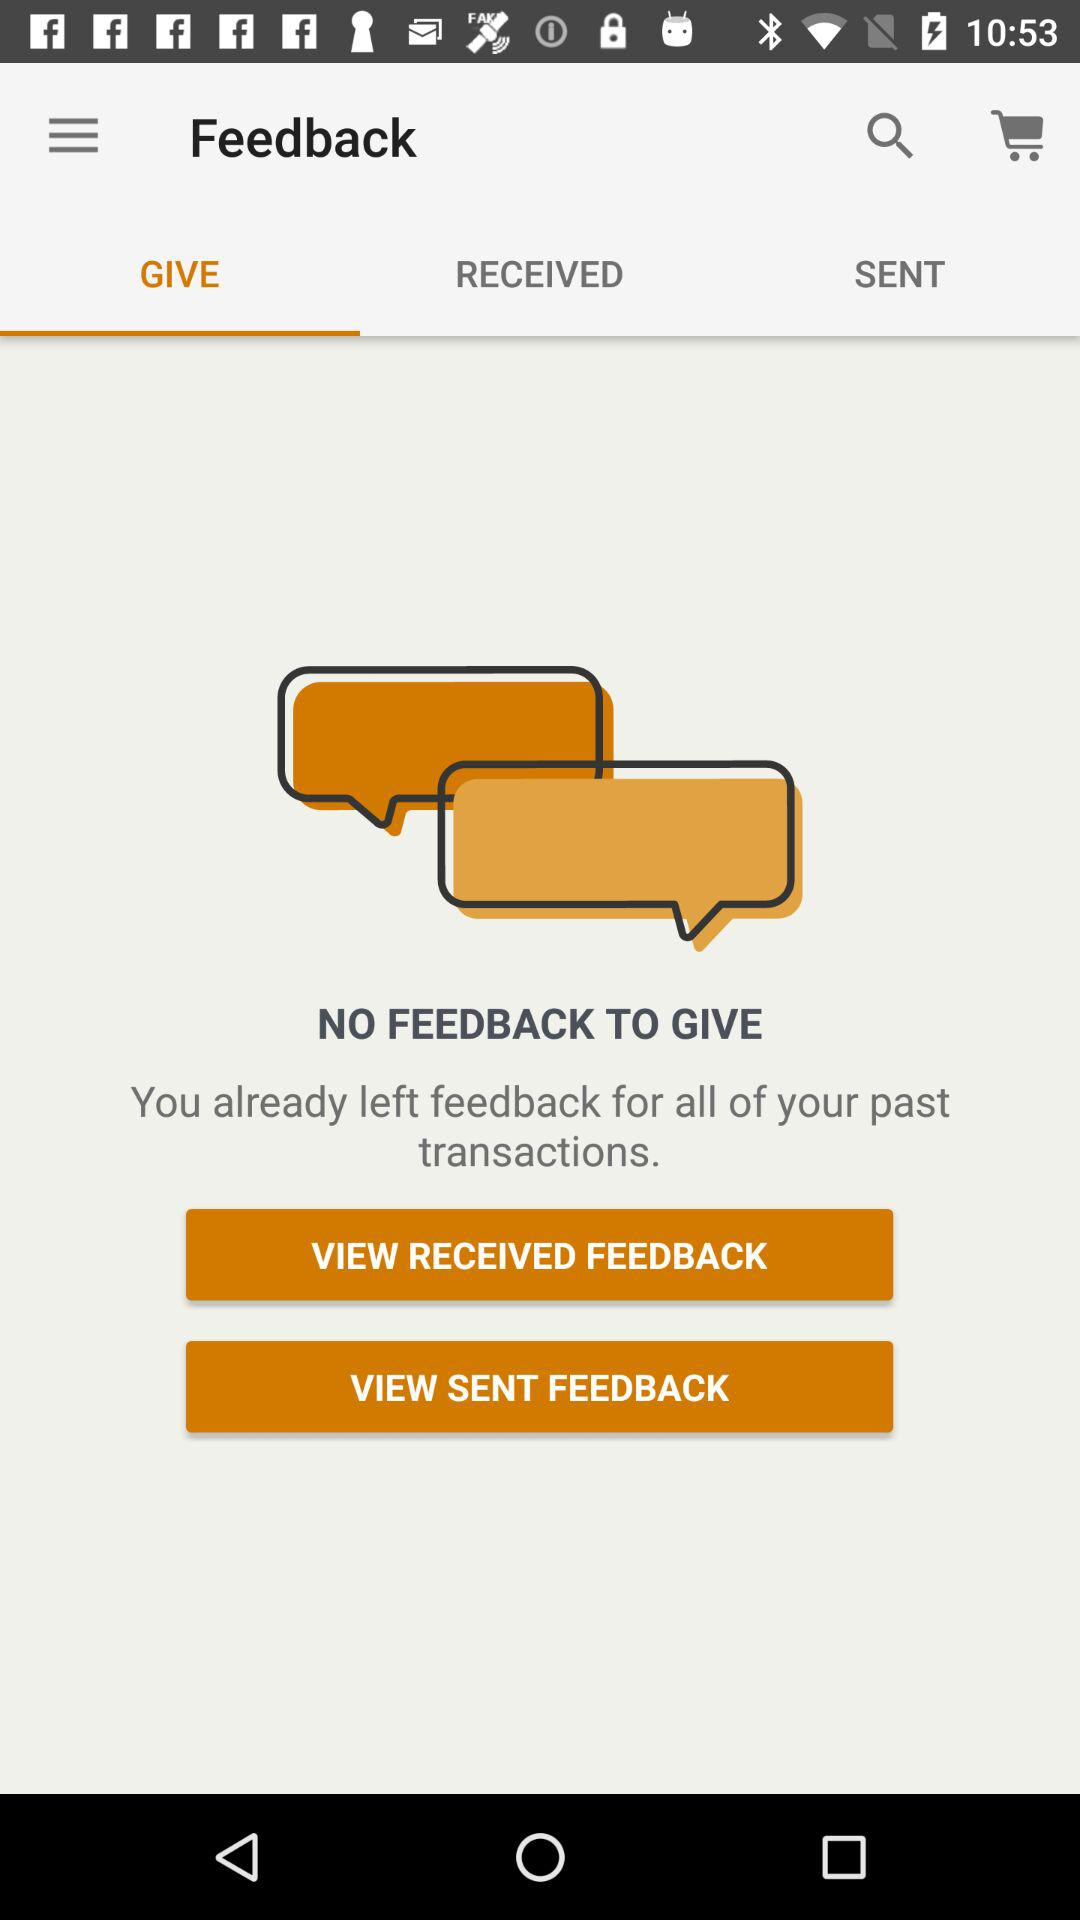Which tab is selected? The selected tab is "GIVE". 